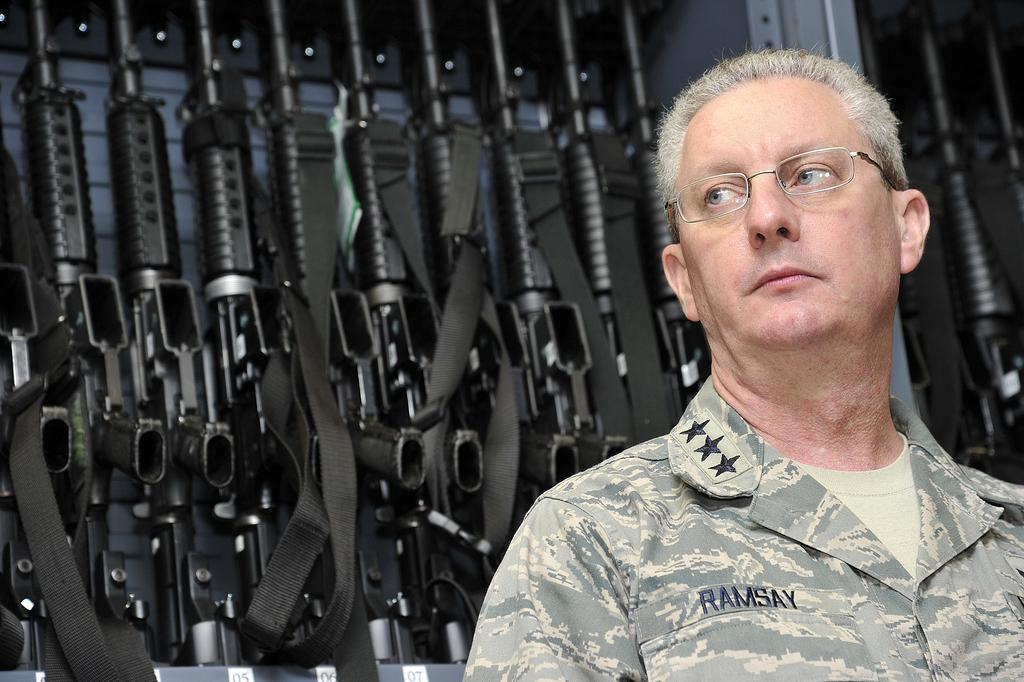What is the main subject of the image? There is a person in the image. What type of clothing is the person wearing? The person is wearing a military dress. What can be seen in the background of the image? There are guns in the background of the image. What is the color of the guns? The guns are black in color. What type of badge is the person wearing on their arithmetic in the image? There is no badge or arithmetic present in the image. How are the guns being used in the image? The image does not show the guns being used; it only shows them in the background. 